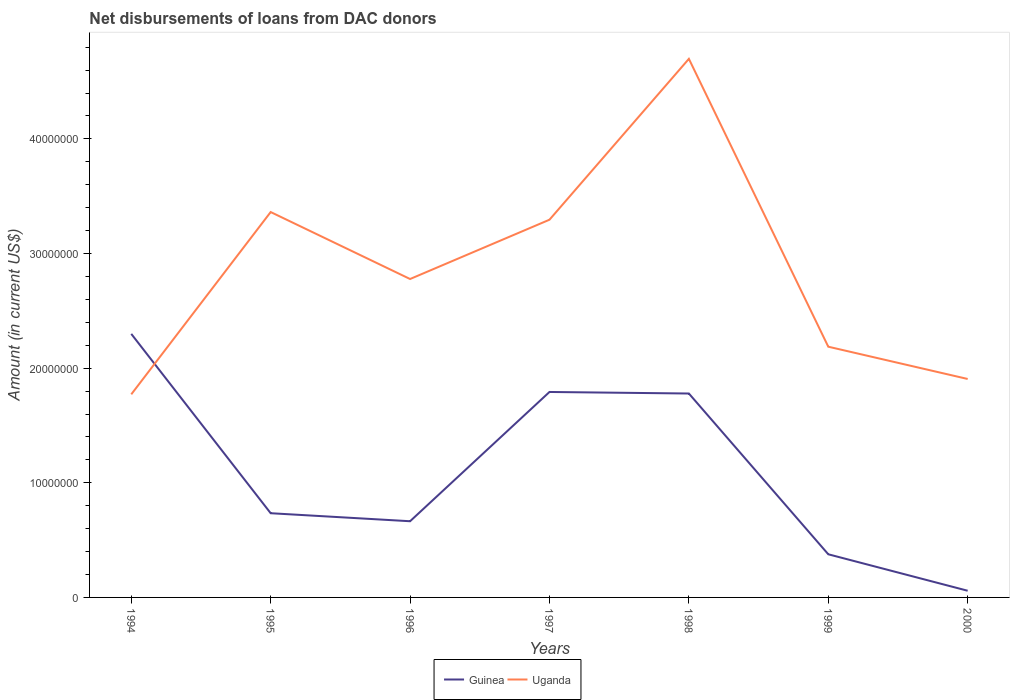How many different coloured lines are there?
Keep it short and to the point. 2. Does the line corresponding to Guinea intersect with the line corresponding to Uganda?
Your answer should be compact. Yes. Across all years, what is the maximum amount of loans disbursed in Guinea?
Offer a very short reply. 5.82e+05. In which year was the amount of loans disbursed in Guinea maximum?
Provide a succinct answer. 2000. What is the total amount of loans disbursed in Uganda in the graph?
Ensure brevity in your answer.  1.39e+07. What is the difference between the highest and the second highest amount of loans disbursed in Uganda?
Your response must be concise. 2.93e+07. What is the difference between the highest and the lowest amount of loans disbursed in Uganda?
Provide a short and direct response. 3. How many lines are there?
Give a very brief answer. 2. How many years are there in the graph?
Offer a very short reply. 7. What is the difference between two consecutive major ticks on the Y-axis?
Provide a succinct answer. 1.00e+07. Are the values on the major ticks of Y-axis written in scientific E-notation?
Provide a succinct answer. No. Does the graph contain any zero values?
Offer a very short reply. No. Where does the legend appear in the graph?
Your response must be concise. Bottom center. How many legend labels are there?
Give a very brief answer. 2. How are the legend labels stacked?
Provide a short and direct response. Horizontal. What is the title of the graph?
Your response must be concise. Net disbursements of loans from DAC donors. What is the label or title of the Y-axis?
Make the answer very short. Amount (in current US$). What is the Amount (in current US$) of Guinea in 1994?
Offer a terse response. 2.30e+07. What is the Amount (in current US$) in Uganda in 1994?
Keep it short and to the point. 1.77e+07. What is the Amount (in current US$) of Guinea in 1995?
Provide a short and direct response. 7.34e+06. What is the Amount (in current US$) of Uganda in 1995?
Your response must be concise. 3.36e+07. What is the Amount (in current US$) in Guinea in 1996?
Ensure brevity in your answer.  6.65e+06. What is the Amount (in current US$) in Uganda in 1996?
Your answer should be compact. 2.78e+07. What is the Amount (in current US$) of Guinea in 1997?
Ensure brevity in your answer.  1.79e+07. What is the Amount (in current US$) in Uganda in 1997?
Offer a very short reply. 3.29e+07. What is the Amount (in current US$) in Guinea in 1998?
Make the answer very short. 1.78e+07. What is the Amount (in current US$) of Uganda in 1998?
Make the answer very short. 4.70e+07. What is the Amount (in current US$) of Guinea in 1999?
Offer a terse response. 3.76e+06. What is the Amount (in current US$) in Uganda in 1999?
Provide a succinct answer. 2.19e+07. What is the Amount (in current US$) of Guinea in 2000?
Make the answer very short. 5.82e+05. What is the Amount (in current US$) in Uganda in 2000?
Your answer should be compact. 1.91e+07. Across all years, what is the maximum Amount (in current US$) of Guinea?
Provide a succinct answer. 2.30e+07. Across all years, what is the maximum Amount (in current US$) in Uganda?
Ensure brevity in your answer.  4.70e+07. Across all years, what is the minimum Amount (in current US$) in Guinea?
Your response must be concise. 5.82e+05. Across all years, what is the minimum Amount (in current US$) in Uganda?
Offer a very short reply. 1.77e+07. What is the total Amount (in current US$) of Guinea in the graph?
Give a very brief answer. 7.70e+07. What is the total Amount (in current US$) in Uganda in the graph?
Offer a terse response. 2.00e+08. What is the difference between the Amount (in current US$) in Guinea in 1994 and that in 1995?
Give a very brief answer. 1.56e+07. What is the difference between the Amount (in current US$) of Uganda in 1994 and that in 1995?
Provide a succinct answer. -1.59e+07. What is the difference between the Amount (in current US$) of Guinea in 1994 and that in 1996?
Your response must be concise. 1.63e+07. What is the difference between the Amount (in current US$) of Uganda in 1994 and that in 1996?
Provide a succinct answer. -1.01e+07. What is the difference between the Amount (in current US$) of Guinea in 1994 and that in 1997?
Provide a short and direct response. 5.07e+06. What is the difference between the Amount (in current US$) of Uganda in 1994 and that in 1997?
Provide a succinct answer. -1.52e+07. What is the difference between the Amount (in current US$) of Guinea in 1994 and that in 1998?
Your answer should be compact. 5.20e+06. What is the difference between the Amount (in current US$) of Uganda in 1994 and that in 1998?
Offer a terse response. -2.93e+07. What is the difference between the Amount (in current US$) of Guinea in 1994 and that in 1999?
Your answer should be compact. 1.92e+07. What is the difference between the Amount (in current US$) in Uganda in 1994 and that in 1999?
Provide a succinct answer. -4.16e+06. What is the difference between the Amount (in current US$) of Guinea in 1994 and that in 2000?
Offer a very short reply. 2.24e+07. What is the difference between the Amount (in current US$) in Uganda in 1994 and that in 2000?
Make the answer very short. -1.34e+06. What is the difference between the Amount (in current US$) in Guinea in 1995 and that in 1996?
Ensure brevity in your answer.  6.99e+05. What is the difference between the Amount (in current US$) of Uganda in 1995 and that in 1996?
Provide a succinct answer. 5.84e+06. What is the difference between the Amount (in current US$) of Guinea in 1995 and that in 1997?
Your response must be concise. -1.06e+07. What is the difference between the Amount (in current US$) in Uganda in 1995 and that in 1997?
Provide a short and direct response. 6.69e+05. What is the difference between the Amount (in current US$) in Guinea in 1995 and that in 1998?
Your answer should be very brief. -1.04e+07. What is the difference between the Amount (in current US$) of Uganda in 1995 and that in 1998?
Your answer should be compact. -1.34e+07. What is the difference between the Amount (in current US$) in Guinea in 1995 and that in 1999?
Your answer should be compact. 3.58e+06. What is the difference between the Amount (in current US$) of Uganda in 1995 and that in 1999?
Your answer should be very brief. 1.17e+07. What is the difference between the Amount (in current US$) in Guinea in 1995 and that in 2000?
Your response must be concise. 6.76e+06. What is the difference between the Amount (in current US$) in Uganda in 1995 and that in 2000?
Make the answer very short. 1.46e+07. What is the difference between the Amount (in current US$) of Guinea in 1996 and that in 1997?
Your response must be concise. -1.13e+07. What is the difference between the Amount (in current US$) of Uganda in 1996 and that in 1997?
Provide a short and direct response. -5.17e+06. What is the difference between the Amount (in current US$) of Guinea in 1996 and that in 1998?
Give a very brief answer. -1.11e+07. What is the difference between the Amount (in current US$) in Uganda in 1996 and that in 1998?
Ensure brevity in your answer.  -1.92e+07. What is the difference between the Amount (in current US$) in Guinea in 1996 and that in 1999?
Give a very brief answer. 2.88e+06. What is the difference between the Amount (in current US$) of Uganda in 1996 and that in 1999?
Ensure brevity in your answer.  5.90e+06. What is the difference between the Amount (in current US$) in Guinea in 1996 and that in 2000?
Make the answer very short. 6.06e+06. What is the difference between the Amount (in current US$) of Uganda in 1996 and that in 2000?
Your answer should be very brief. 8.72e+06. What is the difference between the Amount (in current US$) in Guinea in 1997 and that in 1998?
Offer a terse response. 1.35e+05. What is the difference between the Amount (in current US$) of Uganda in 1997 and that in 1998?
Offer a very short reply. -1.40e+07. What is the difference between the Amount (in current US$) in Guinea in 1997 and that in 1999?
Your response must be concise. 1.42e+07. What is the difference between the Amount (in current US$) in Uganda in 1997 and that in 1999?
Ensure brevity in your answer.  1.11e+07. What is the difference between the Amount (in current US$) of Guinea in 1997 and that in 2000?
Give a very brief answer. 1.73e+07. What is the difference between the Amount (in current US$) in Uganda in 1997 and that in 2000?
Your answer should be compact. 1.39e+07. What is the difference between the Amount (in current US$) in Guinea in 1998 and that in 1999?
Keep it short and to the point. 1.40e+07. What is the difference between the Amount (in current US$) in Uganda in 1998 and that in 1999?
Your answer should be compact. 2.51e+07. What is the difference between the Amount (in current US$) of Guinea in 1998 and that in 2000?
Ensure brevity in your answer.  1.72e+07. What is the difference between the Amount (in current US$) of Uganda in 1998 and that in 2000?
Give a very brief answer. 2.79e+07. What is the difference between the Amount (in current US$) in Guinea in 1999 and that in 2000?
Make the answer very short. 3.18e+06. What is the difference between the Amount (in current US$) of Uganda in 1999 and that in 2000?
Keep it short and to the point. 2.82e+06. What is the difference between the Amount (in current US$) in Guinea in 1994 and the Amount (in current US$) in Uganda in 1995?
Your answer should be compact. -1.06e+07. What is the difference between the Amount (in current US$) in Guinea in 1994 and the Amount (in current US$) in Uganda in 1996?
Offer a very short reply. -4.79e+06. What is the difference between the Amount (in current US$) of Guinea in 1994 and the Amount (in current US$) of Uganda in 1997?
Keep it short and to the point. -9.96e+06. What is the difference between the Amount (in current US$) of Guinea in 1994 and the Amount (in current US$) of Uganda in 1998?
Give a very brief answer. -2.40e+07. What is the difference between the Amount (in current US$) of Guinea in 1994 and the Amount (in current US$) of Uganda in 1999?
Offer a very short reply. 1.12e+06. What is the difference between the Amount (in current US$) in Guinea in 1994 and the Amount (in current US$) in Uganda in 2000?
Offer a terse response. 3.93e+06. What is the difference between the Amount (in current US$) in Guinea in 1995 and the Amount (in current US$) in Uganda in 1996?
Provide a short and direct response. -2.04e+07. What is the difference between the Amount (in current US$) in Guinea in 1995 and the Amount (in current US$) in Uganda in 1997?
Give a very brief answer. -2.56e+07. What is the difference between the Amount (in current US$) of Guinea in 1995 and the Amount (in current US$) of Uganda in 1998?
Provide a succinct answer. -3.96e+07. What is the difference between the Amount (in current US$) in Guinea in 1995 and the Amount (in current US$) in Uganda in 1999?
Offer a terse response. -1.45e+07. What is the difference between the Amount (in current US$) of Guinea in 1995 and the Amount (in current US$) of Uganda in 2000?
Your response must be concise. -1.17e+07. What is the difference between the Amount (in current US$) of Guinea in 1996 and the Amount (in current US$) of Uganda in 1997?
Provide a succinct answer. -2.63e+07. What is the difference between the Amount (in current US$) of Guinea in 1996 and the Amount (in current US$) of Uganda in 1998?
Your answer should be very brief. -4.03e+07. What is the difference between the Amount (in current US$) of Guinea in 1996 and the Amount (in current US$) of Uganda in 1999?
Your answer should be compact. -1.52e+07. What is the difference between the Amount (in current US$) in Guinea in 1996 and the Amount (in current US$) in Uganda in 2000?
Your response must be concise. -1.24e+07. What is the difference between the Amount (in current US$) of Guinea in 1997 and the Amount (in current US$) of Uganda in 1998?
Provide a succinct answer. -2.91e+07. What is the difference between the Amount (in current US$) of Guinea in 1997 and the Amount (in current US$) of Uganda in 1999?
Provide a succinct answer. -3.95e+06. What is the difference between the Amount (in current US$) in Guinea in 1997 and the Amount (in current US$) in Uganda in 2000?
Your response must be concise. -1.13e+06. What is the difference between the Amount (in current US$) in Guinea in 1998 and the Amount (in current US$) in Uganda in 1999?
Your response must be concise. -4.08e+06. What is the difference between the Amount (in current US$) of Guinea in 1998 and the Amount (in current US$) of Uganda in 2000?
Make the answer very short. -1.27e+06. What is the difference between the Amount (in current US$) in Guinea in 1999 and the Amount (in current US$) in Uganda in 2000?
Your answer should be very brief. -1.53e+07. What is the average Amount (in current US$) in Guinea per year?
Give a very brief answer. 1.10e+07. What is the average Amount (in current US$) in Uganda per year?
Make the answer very short. 2.86e+07. In the year 1994, what is the difference between the Amount (in current US$) in Guinea and Amount (in current US$) in Uganda?
Offer a terse response. 5.27e+06. In the year 1995, what is the difference between the Amount (in current US$) of Guinea and Amount (in current US$) of Uganda?
Your answer should be compact. -2.63e+07. In the year 1996, what is the difference between the Amount (in current US$) of Guinea and Amount (in current US$) of Uganda?
Your answer should be very brief. -2.11e+07. In the year 1997, what is the difference between the Amount (in current US$) of Guinea and Amount (in current US$) of Uganda?
Offer a very short reply. -1.50e+07. In the year 1998, what is the difference between the Amount (in current US$) of Guinea and Amount (in current US$) of Uganda?
Your answer should be very brief. -2.92e+07. In the year 1999, what is the difference between the Amount (in current US$) in Guinea and Amount (in current US$) in Uganda?
Give a very brief answer. -1.81e+07. In the year 2000, what is the difference between the Amount (in current US$) in Guinea and Amount (in current US$) in Uganda?
Provide a short and direct response. -1.85e+07. What is the ratio of the Amount (in current US$) in Guinea in 1994 to that in 1995?
Your answer should be compact. 3.13. What is the ratio of the Amount (in current US$) in Uganda in 1994 to that in 1995?
Provide a succinct answer. 0.53. What is the ratio of the Amount (in current US$) of Guinea in 1994 to that in 1996?
Give a very brief answer. 3.46. What is the ratio of the Amount (in current US$) in Uganda in 1994 to that in 1996?
Your answer should be very brief. 0.64. What is the ratio of the Amount (in current US$) of Guinea in 1994 to that in 1997?
Keep it short and to the point. 1.28. What is the ratio of the Amount (in current US$) in Uganda in 1994 to that in 1997?
Your response must be concise. 0.54. What is the ratio of the Amount (in current US$) in Guinea in 1994 to that in 1998?
Provide a succinct answer. 1.29. What is the ratio of the Amount (in current US$) in Uganda in 1994 to that in 1998?
Offer a terse response. 0.38. What is the ratio of the Amount (in current US$) of Guinea in 1994 to that in 1999?
Offer a terse response. 6.11. What is the ratio of the Amount (in current US$) in Uganda in 1994 to that in 1999?
Provide a short and direct response. 0.81. What is the ratio of the Amount (in current US$) in Guinea in 1994 to that in 2000?
Your response must be concise. 39.5. What is the ratio of the Amount (in current US$) of Uganda in 1994 to that in 2000?
Your response must be concise. 0.93. What is the ratio of the Amount (in current US$) of Guinea in 1995 to that in 1996?
Make the answer very short. 1.11. What is the ratio of the Amount (in current US$) in Uganda in 1995 to that in 1996?
Your response must be concise. 1.21. What is the ratio of the Amount (in current US$) of Guinea in 1995 to that in 1997?
Offer a terse response. 0.41. What is the ratio of the Amount (in current US$) in Uganda in 1995 to that in 1997?
Your answer should be compact. 1.02. What is the ratio of the Amount (in current US$) of Guinea in 1995 to that in 1998?
Give a very brief answer. 0.41. What is the ratio of the Amount (in current US$) of Uganda in 1995 to that in 1998?
Give a very brief answer. 0.72. What is the ratio of the Amount (in current US$) in Guinea in 1995 to that in 1999?
Your answer should be very brief. 1.95. What is the ratio of the Amount (in current US$) of Uganda in 1995 to that in 1999?
Keep it short and to the point. 1.54. What is the ratio of the Amount (in current US$) of Guinea in 1995 to that in 2000?
Give a very brief answer. 12.62. What is the ratio of the Amount (in current US$) in Uganda in 1995 to that in 2000?
Make the answer very short. 1.76. What is the ratio of the Amount (in current US$) of Guinea in 1996 to that in 1997?
Make the answer very short. 0.37. What is the ratio of the Amount (in current US$) of Uganda in 1996 to that in 1997?
Provide a succinct answer. 0.84. What is the ratio of the Amount (in current US$) of Guinea in 1996 to that in 1998?
Offer a terse response. 0.37. What is the ratio of the Amount (in current US$) in Uganda in 1996 to that in 1998?
Offer a terse response. 0.59. What is the ratio of the Amount (in current US$) of Guinea in 1996 to that in 1999?
Keep it short and to the point. 1.77. What is the ratio of the Amount (in current US$) of Uganda in 1996 to that in 1999?
Keep it short and to the point. 1.27. What is the ratio of the Amount (in current US$) in Guinea in 1996 to that in 2000?
Your answer should be compact. 11.42. What is the ratio of the Amount (in current US$) in Uganda in 1996 to that in 2000?
Your answer should be compact. 1.46. What is the ratio of the Amount (in current US$) in Guinea in 1997 to that in 1998?
Keep it short and to the point. 1.01. What is the ratio of the Amount (in current US$) in Uganda in 1997 to that in 1998?
Your answer should be very brief. 0.7. What is the ratio of the Amount (in current US$) of Guinea in 1997 to that in 1999?
Ensure brevity in your answer.  4.76. What is the ratio of the Amount (in current US$) of Uganda in 1997 to that in 1999?
Provide a succinct answer. 1.51. What is the ratio of the Amount (in current US$) in Guinea in 1997 to that in 2000?
Make the answer very short. 30.79. What is the ratio of the Amount (in current US$) of Uganda in 1997 to that in 2000?
Make the answer very short. 1.73. What is the ratio of the Amount (in current US$) in Guinea in 1998 to that in 1999?
Give a very brief answer. 4.73. What is the ratio of the Amount (in current US$) in Uganda in 1998 to that in 1999?
Give a very brief answer. 2.15. What is the ratio of the Amount (in current US$) of Guinea in 1998 to that in 2000?
Your answer should be very brief. 30.56. What is the ratio of the Amount (in current US$) in Uganda in 1998 to that in 2000?
Provide a short and direct response. 2.47. What is the ratio of the Amount (in current US$) in Guinea in 1999 to that in 2000?
Provide a short and direct response. 6.47. What is the ratio of the Amount (in current US$) in Uganda in 1999 to that in 2000?
Provide a short and direct response. 1.15. What is the difference between the highest and the second highest Amount (in current US$) in Guinea?
Provide a short and direct response. 5.07e+06. What is the difference between the highest and the second highest Amount (in current US$) in Uganda?
Keep it short and to the point. 1.34e+07. What is the difference between the highest and the lowest Amount (in current US$) in Guinea?
Your answer should be very brief. 2.24e+07. What is the difference between the highest and the lowest Amount (in current US$) of Uganda?
Offer a very short reply. 2.93e+07. 